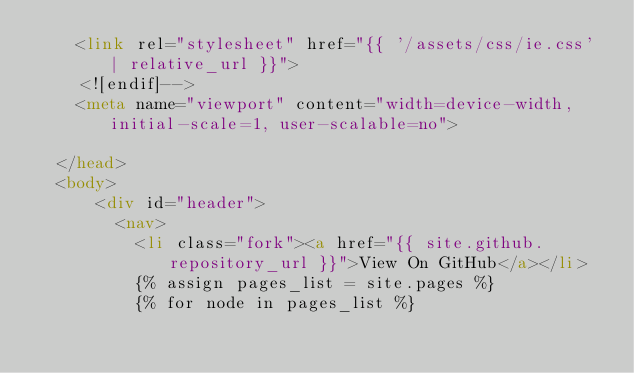<code> <loc_0><loc_0><loc_500><loc_500><_HTML_>    <link rel="stylesheet" href="{{ '/assets/css/ie.css' | relative_url }}">
    <![endif]-->
    <meta name="viewport" content="width=device-width, initial-scale=1, user-scalable=no">

  </head>
  <body>
      <div id="header">
        <nav>
          <li class="fork"><a href="{{ site.github.repository_url }}">View On GitHub</a></li>
          {% assign pages_list = site.pages %}
          {% for node in pages_list %}</code> 